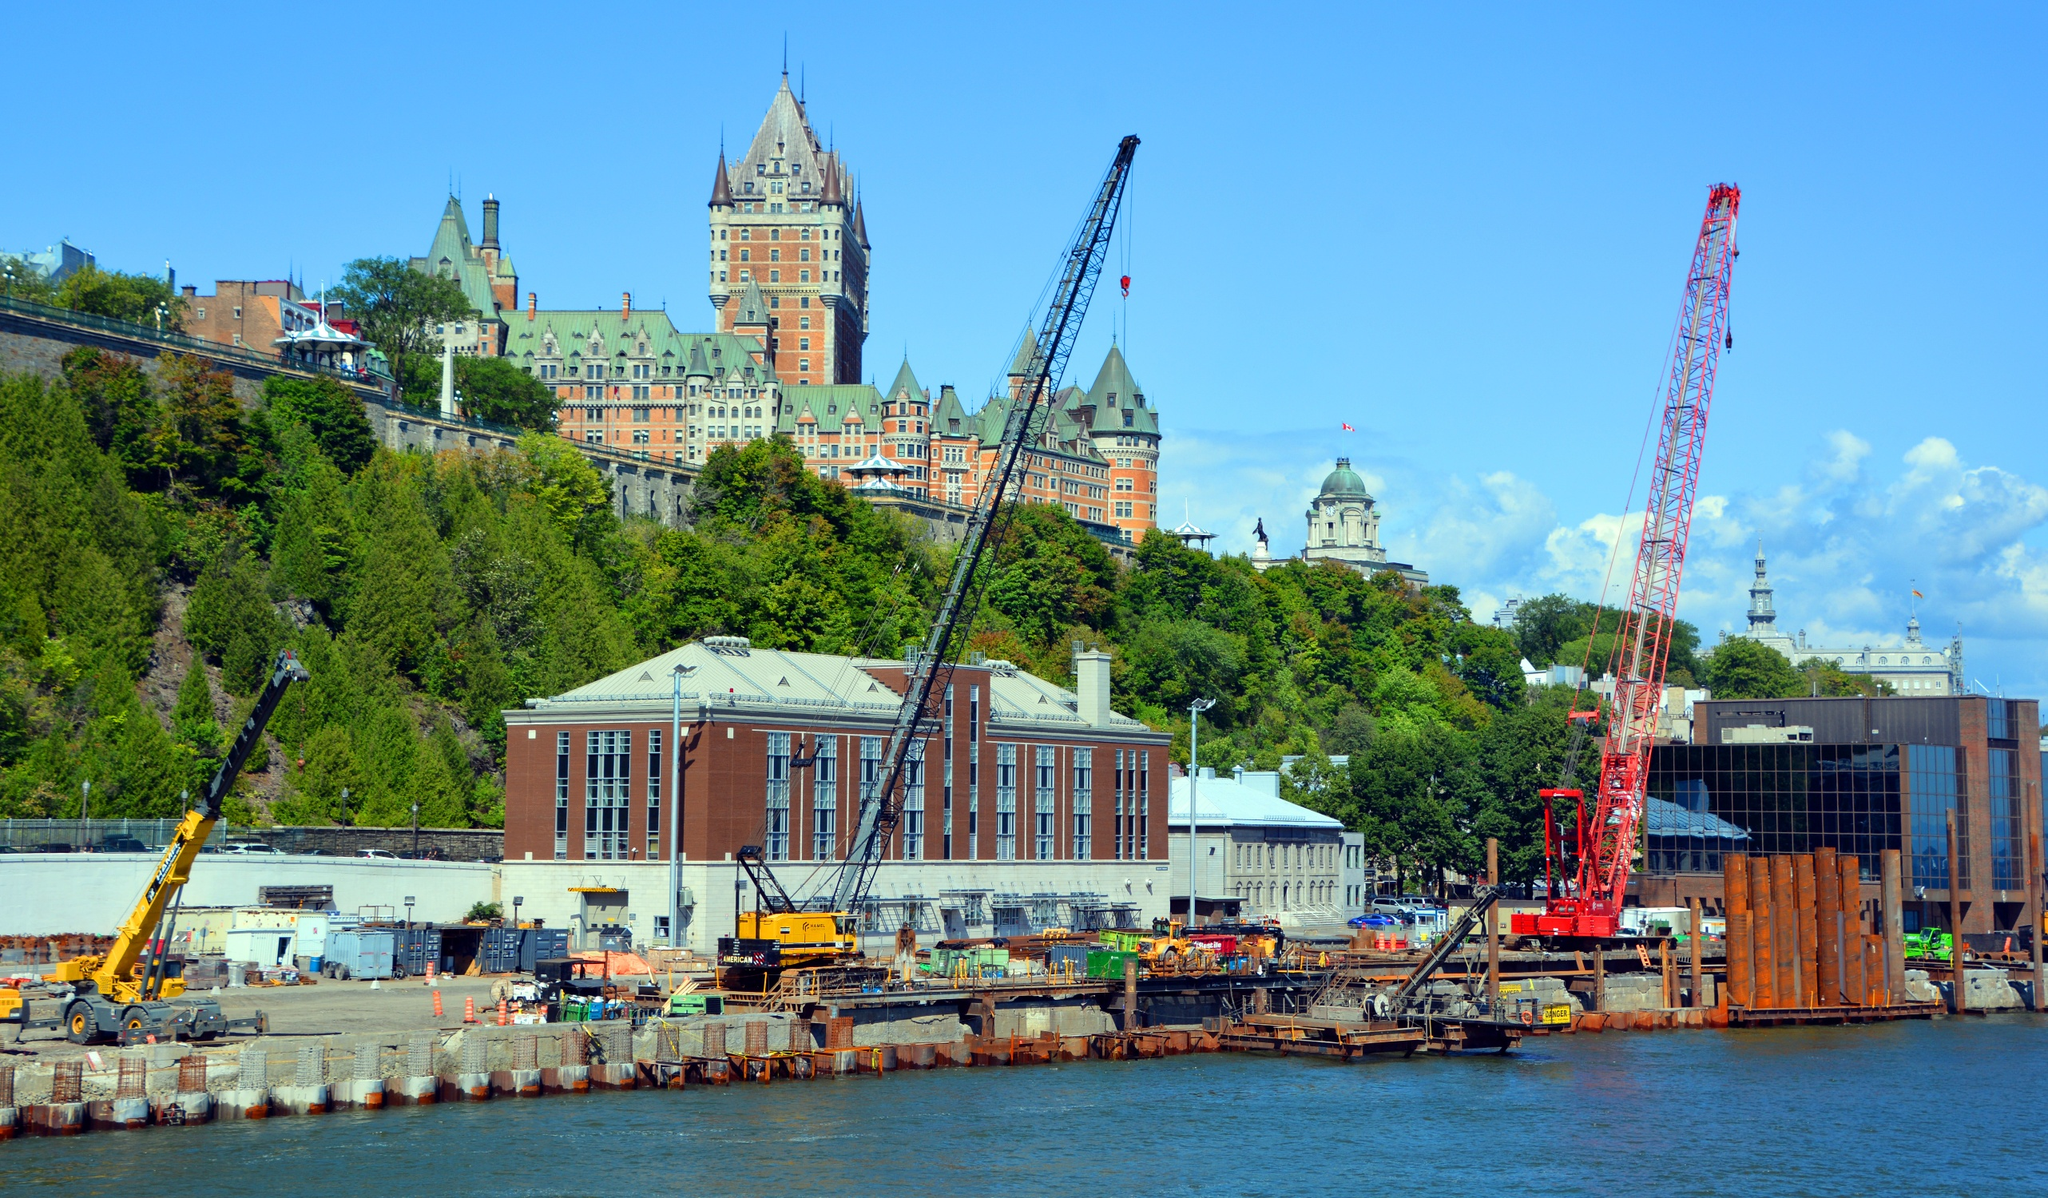Can you list some of the materials and equipment visible at the construction site? Visible at the construction site are various cranes, including a prominent red one and smaller yellow hydraulic cranes. There are also stacks of metal beams, construction trailers, and concrete barriers lining the edge of the water. Additional materials include pipes, wooden planks, and other construction supplies that indicate active and diverse building activities. The site is a bustling hub of development with clearly identified equipment and materials essential for structural work. Can you imagine the future development of this construction site? The future development of this construction site could lead to a state-of-the-art waterfront complex, perhaps incorporating commercial spaces, residential units, and cultural venues. With modern architectural designs seamlessly blending with the historical ambiance of Quebec City, the new structures might feature innovative green spaces and public areas for recreation and community gatherings. Sustainability could be a core focus, with buildings utilizing energy-efficient technologies and materials. Over time, this development would become a bustling center of activity, enhancing the vibrancy of the city while respecting and highlighting its historical context. 